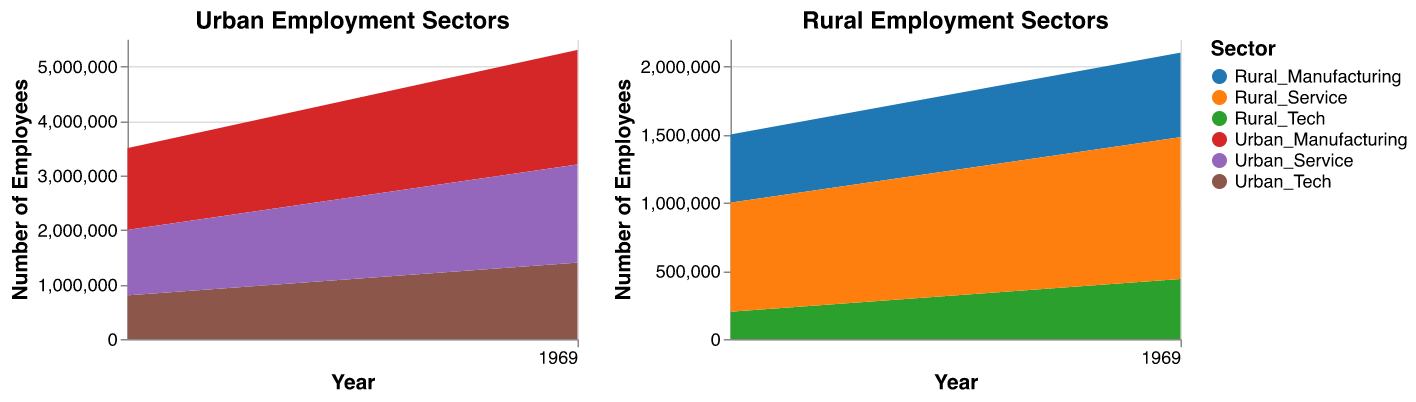What's the title of the left area chart? The left area chart has a title that indicates it represents data about urban employment sectors. The title is shown at the top of the chart.
Answer: Urban Employment Sectors How has employment in rural manufacturing changed from 2010 to 2022? To determine the change in rural manufacturing employment from 2010 to 2022, find the value in 2022 and subtract the value in 2010. In 2010, it was 500,000, and in 2022, it is 620,000. The change is 620,000 - 500,000.
Answer: 120,000 Which sector has the highest number of employees in urban areas by 2022? Look at the data for 2022 in the urban area chart and find the highest number of employees among the sectors. Urban Manufacturing has 2,100,000 employees, Urban Tech has 1,400,000 employees, and Urban Service has 1,800,000 employees.
Answer: Urban Manufacturing By how much did employment in rural tech increase from 2011 to 2016? To find the increase, subtract the number of employees in rural tech in 2011 from the number of employees in rural tech in 2016. In 2011, it was 220,000. In 2016, it was 320,000. The increase is 320,000 - 220,000.
Answer: 100,000 Compare the growth trends of urban manufacturing and rural manufacturing from 2010 to 2022. Examine the trends in the charts for urban and rural manufacturing. Urban manufacturing shows a consistent rise from 1,500,000 in 2010 to 2,100,000 in 2022. Rural manufacturing also shows a consistent rise from 500,000 in 2010 to 620,000 in 2022. Both sectors show growth, but urban manufacturing grows by 600,000 while rural manufacturing grows by 120,000.
Answer: Urban manufacturing grew consistently and more significantly than rural manufacturing What sector in urban areas saw the greatest increase in employment between 2015 and 2020? Look at the data points for 2015 and 2020 for each sector in urban areas. Urban Manufacturing increased from 1,750,000 to 2,000,000 (250,000 increase), Urban Tech increased from 1,050,000 to 1,300,000 (250,000 increase), and Urban Service increased from 1,450,000 to 1,700,000 (250,000 increase). All sectors saw the same increase.
Answer: All sectors saw the same increase Which rural sector started with the lowest employment in 2010, and how many employees were there? Identify the sector with the lowest value in 2010 in the rural areas chart. Rural Tech had 200,000 employees, which is the lowest among the sectors.
Answer: Rural Tech with 200,000 employees What is the total employment in urban sectors in 2012? Add the employment numbers for all urban sectors in 2012: Manufacturing (1,600,000), Tech (900,000), and Service (1,300,000). Sum them up: 1,600,000 + 900,000 + 1,300,000.
Answer: 3,800,000 Determine the sector with the least growth in the rural areas from 2010 to 2022. Calculate the difference between 2022 and 2010 for each rural sector. Rural Manufacturing grew from 500,000 to 620,000 (120,000 increase), Rural Tech from 200,000 to 440,000 (240,000 increase), and Rural Service from 800,000 to 1,040,000 (240,000 increase). The least growth is in Rural Manufacturing.
Answer: Rural Manufacturing 